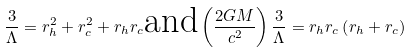Convert formula to latex. <formula><loc_0><loc_0><loc_500><loc_500>\frac { 3 } { \Lambda } = r _ { h } ^ { 2 } + r _ { c } ^ { 2 } + r _ { h } r _ { c } \text {and} \left ( \frac { 2 G M } { c ^ { 2 } } \right ) \frac { 3 } { \Lambda } = r _ { h } r _ { c } \left ( r _ { h } + r _ { c } \right )</formula> 